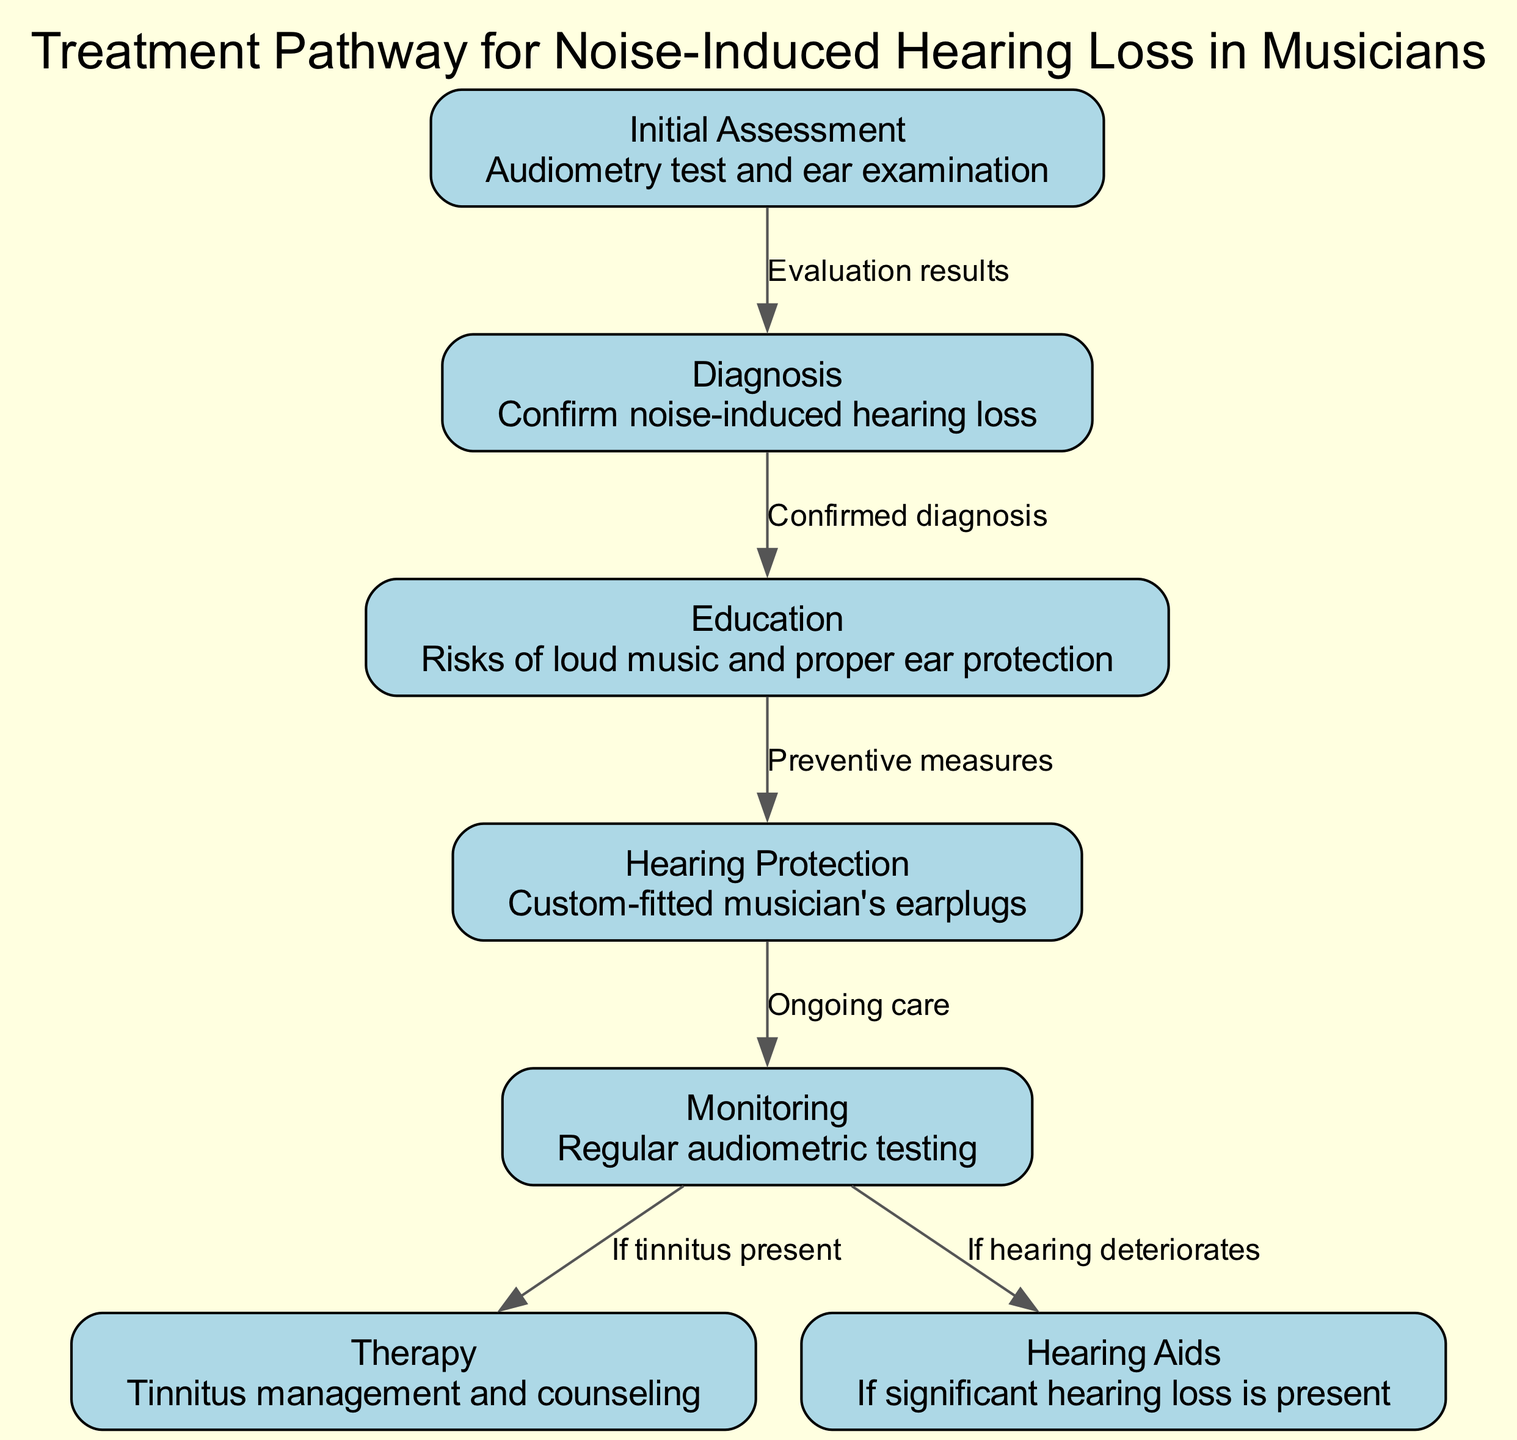What is the first step in the treatment pathway? The first node in the diagram indicates "Initial Assessment," which includes an audiometry test and ear examination.
Answer: Initial Assessment How many nodes are there in the diagram? By counting the nodes listed in the diagram, we find that there are a total of 7 nodes.
Answer: 7 What is the relationship between Diagnosis and Education? The edge connecting these two nodes is labeled "Confirmed diagnosis," which indicates that Education follows the Diagnosis step once it is confirmed.
Answer: Confirmed diagnosis What action follows Hearing Protection? The edge from Hearing Protection to Monitoring is labeled "Ongoing care," indicating that after fitting hearing protection, regular monitoring is the next action taken.
Answer: Ongoing care If tinnitus is present, what therapy is indicated next? The edge leading from Monitoring to Therapy is labeled "If tinnitus present," which signifies that Therapy occurs next if tinnitus is present during monitoring.
Answer: Therapy What is provided if there is significant hearing loss? The edge from Monitoring to Hearing Aids reads "If hearing deteriorates," meaning that hearing aids would be provided if significant hearing loss is confirmed.
Answer: Hearing Aids What are musicians educated about? The Education node mentions "Risks of loud music and proper ear protection," indicating the key topics musicians are educated on.
Answer: Risks of loud music and proper ear protection What is the purpose of the Monitoring step? The Monitoring node signifies "Regular audiometric testing," implying that its purpose is to regularly assess hearing levels over time.
Answer: Regular audiometric testing Which step comes after Initial Assessment? The step that follows Initial Assessment, as indicated in the diagram, is Diagnosis, marked by the edge labeled "Evaluation results."
Answer: Diagnosis 